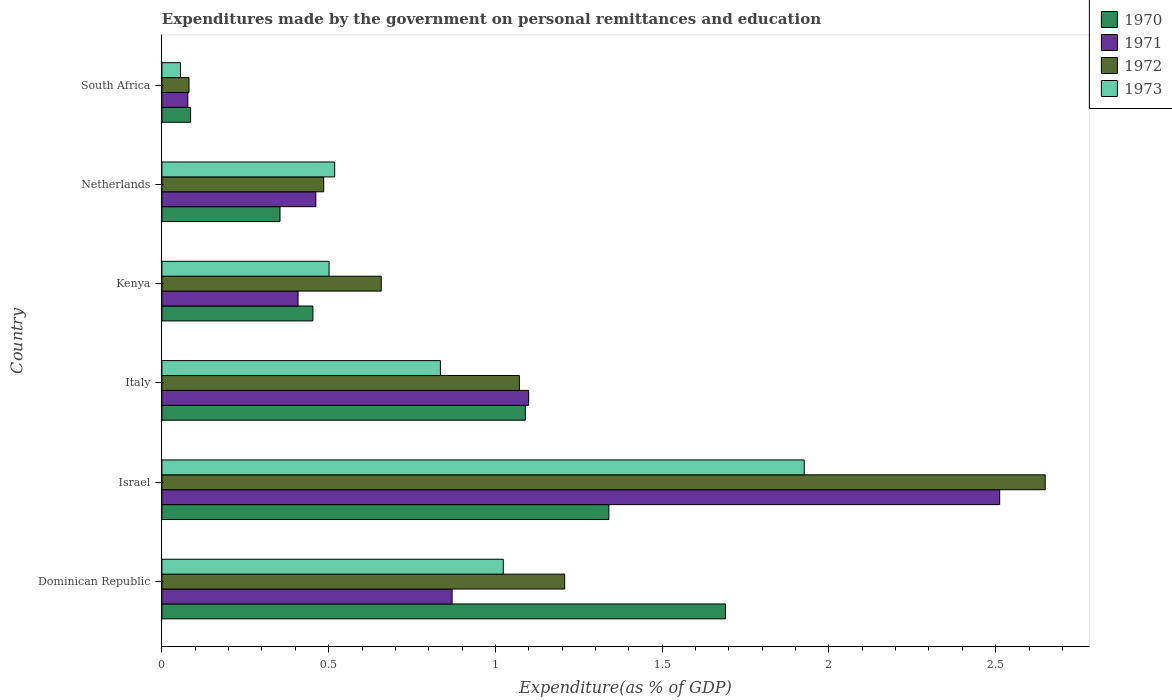How many different coloured bars are there?
Provide a succinct answer. 4. How many groups of bars are there?
Give a very brief answer. 6. How many bars are there on the 4th tick from the top?
Your answer should be very brief. 4. What is the label of the 2nd group of bars from the top?
Your answer should be very brief. Netherlands. What is the expenditures made by the government on personal remittances and education in 1971 in Kenya?
Your response must be concise. 0.41. Across all countries, what is the maximum expenditures made by the government on personal remittances and education in 1971?
Offer a terse response. 2.51. Across all countries, what is the minimum expenditures made by the government on personal remittances and education in 1971?
Your answer should be very brief. 0.08. In which country was the expenditures made by the government on personal remittances and education in 1971 minimum?
Give a very brief answer. South Africa. What is the total expenditures made by the government on personal remittances and education in 1972 in the graph?
Provide a short and direct response. 6.15. What is the difference between the expenditures made by the government on personal remittances and education in 1971 in Israel and that in Italy?
Provide a short and direct response. 1.41. What is the difference between the expenditures made by the government on personal remittances and education in 1970 in Israel and the expenditures made by the government on personal remittances and education in 1973 in South Africa?
Your answer should be very brief. 1.28. What is the average expenditures made by the government on personal remittances and education in 1970 per country?
Your response must be concise. 0.84. What is the difference between the expenditures made by the government on personal remittances and education in 1971 and expenditures made by the government on personal remittances and education in 1973 in Kenya?
Ensure brevity in your answer.  -0.09. What is the ratio of the expenditures made by the government on personal remittances and education in 1973 in Dominican Republic to that in Kenya?
Your response must be concise. 2.04. Is the expenditures made by the government on personal remittances and education in 1972 in Dominican Republic less than that in Israel?
Make the answer very short. Yes. Is the difference between the expenditures made by the government on personal remittances and education in 1971 in Israel and Netherlands greater than the difference between the expenditures made by the government on personal remittances and education in 1973 in Israel and Netherlands?
Offer a terse response. Yes. What is the difference between the highest and the second highest expenditures made by the government on personal remittances and education in 1972?
Provide a succinct answer. 1.44. What is the difference between the highest and the lowest expenditures made by the government on personal remittances and education in 1972?
Make the answer very short. 2.57. Is the sum of the expenditures made by the government on personal remittances and education in 1971 in Dominican Republic and South Africa greater than the maximum expenditures made by the government on personal remittances and education in 1970 across all countries?
Keep it short and to the point. No. Is it the case that in every country, the sum of the expenditures made by the government on personal remittances and education in 1973 and expenditures made by the government on personal remittances and education in 1972 is greater than the sum of expenditures made by the government on personal remittances and education in 1971 and expenditures made by the government on personal remittances and education in 1970?
Give a very brief answer. No. What does the 1st bar from the top in South Africa represents?
Provide a short and direct response. 1973. What does the 2nd bar from the bottom in South Africa represents?
Provide a succinct answer. 1971. How many bars are there?
Offer a terse response. 24. Are all the bars in the graph horizontal?
Offer a terse response. Yes. How many countries are there in the graph?
Your answer should be very brief. 6. Are the values on the major ticks of X-axis written in scientific E-notation?
Offer a terse response. No. Where does the legend appear in the graph?
Give a very brief answer. Top right. How many legend labels are there?
Offer a very short reply. 4. How are the legend labels stacked?
Ensure brevity in your answer.  Vertical. What is the title of the graph?
Provide a short and direct response. Expenditures made by the government on personal remittances and education. Does "1966" appear as one of the legend labels in the graph?
Offer a terse response. No. What is the label or title of the X-axis?
Offer a very short reply. Expenditure(as % of GDP). What is the Expenditure(as % of GDP) in 1970 in Dominican Republic?
Keep it short and to the point. 1.69. What is the Expenditure(as % of GDP) in 1971 in Dominican Republic?
Keep it short and to the point. 0.87. What is the Expenditure(as % of GDP) in 1972 in Dominican Republic?
Offer a terse response. 1.21. What is the Expenditure(as % of GDP) of 1973 in Dominican Republic?
Your response must be concise. 1.02. What is the Expenditure(as % of GDP) of 1970 in Israel?
Offer a very short reply. 1.34. What is the Expenditure(as % of GDP) of 1971 in Israel?
Offer a terse response. 2.51. What is the Expenditure(as % of GDP) of 1972 in Israel?
Your answer should be very brief. 2.65. What is the Expenditure(as % of GDP) of 1973 in Israel?
Provide a succinct answer. 1.93. What is the Expenditure(as % of GDP) of 1970 in Italy?
Your answer should be very brief. 1.09. What is the Expenditure(as % of GDP) of 1971 in Italy?
Provide a succinct answer. 1.1. What is the Expenditure(as % of GDP) of 1972 in Italy?
Ensure brevity in your answer.  1.07. What is the Expenditure(as % of GDP) in 1973 in Italy?
Provide a succinct answer. 0.84. What is the Expenditure(as % of GDP) in 1970 in Kenya?
Your answer should be very brief. 0.45. What is the Expenditure(as % of GDP) of 1971 in Kenya?
Provide a short and direct response. 0.41. What is the Expenditure(as % of GDP) of 1972 in Kenya?
Offer a terse response. 0.66. What is the Expenditure(as % of GDP) in 1973 in Kenya?
Make the answer very short. 0.5. What is the Expenditure(as % of GDP) in 1970 in Netherlands?
Your answer should be very brief. 0.35. What is the Expenditure(as % of GDP) in 1971 in Netherlands?
Offer a very short reply. 0.46. What is the Expenditure(as % of GDP) in 1972 in Netherlands?
Make the answer very short. 0.49. What is the Expenditure(as % of GDP) of 1973 in Netherlands?
Ensure brevity in your answer.  0.52. What is the Expenditure(as % of GDP) in 1970 in South Africa?
Your answer should be very brief. 0.09. What is the Expenditure(as % of GDP) in 1971 in South Africa?
Your answer should be compact. 0.08. What is the Expenditure(as % of GDP) in 1972 in South Africa?
Your answer should be very brief. 0.08. What is the Expenditure(as % of GDP) of 1973 in South Africa?
Give a very brief answer. 0.06. Across all countries, what is the maximum Expenditure(as % of GDP) in 1970?
Your answer should be very brief. 1.69. Across all countries, what is the maximum Expenditure(as % of GDP) of 1971?
Your answer should be very brief. 2.51. Across all countries, what is the maximum Expenditure(as % of GDP) of 1972?
Make the answer very short. 2.65. Across all countries, what is the maximum Expenditure(as % of GDP) in 1973?
Ensure brevity in your answer.  1.93. Across all countries, what is the minimum Expenditure(as % of GDP) of 1970?
Ensure brevity in your answer.  0.09. Across all countries, what is the minimum Expenditure(as % of GDP) of 1971?
Offer a very short reply. 0.08. Across all countries, what is the minimum Expenditure(as % of GDP) of 1972?
Ensure brevity in your answer.  0.08. Across all countries, what is the minimum Expenditure(as % of GDP) of 1973?
Ensure brevity in your answer.  0.06. What is the total Expenditure(as % of GDP) in 1970 in the graph?
Your response must be concise. 5.01. What is the total Expenditure(as % of GDP) in 1971 in the graph?
Offer a terse response. 5.43. What is the total Expenditure(as % of GDP) in 1972 in the graph?
Keep it short and to the point. 6.15. What is the total Expenditure(as % of GDP) of 1973 in the graph?
Ensure brevity in your answer.  4.86. What is the difference between the Expenditure(as % of GDP) of 1970 in Dominican Republic and that in Israel?
Give a very brief answer. 0.35. What is the difference between the Expenditure(as % of GDP) in 1971 in Dominican Republic and that in Israel?
Offer a very short reply. -1.64. What is the difference between the Expenditure(as % of GDP) of 1972 in Dominican Republic and that in Israel?
Provide a succinct answer. -1.44. What is the difference between the Expenditure(as % of GDP) of 1973 in Dominican Republic and that in Israel?
Provide a succinct answer. -0.9. What is the difference between the Expenditure(as % of GDP) of 1970 in Dominican Republic and that in Italy?
Provide a succinct answer. 0.6. What is the difference between the Expenditure(as % of GDP) in 1971 in Dominican Republic and that in Italy?
Provide a short and direct response. -0.23. What is the difference between the Expenditure(as % of GDP) in 1972 in Dominican Republic and that in Italy?
Provide a short and direct response. 0.14. What is the difference between the Expenditure(as % of GDP) of 1973 in Dominican Republic and that in Italy?
Make the answer very short. 0.19. What is the difference between the Expenditure(as % of GDP) of 1970 in Dominican Republic and that in Kenya?
Keep it short and to the point. 1.24. What is the difference between the Expenditure(as % of GDP) in 1971 in Dominican Republic and that in Kenya?
Your answer should be very brief. 0.46. What is the difference between the Expenditure(as % of GDP) of 1972 in Dominican Republic and that in Kenya?
Give a very brief answer. 0.55. What is the difference between the Expenditure(as % of GDP) of 1973 in Dominican Republic and that in Kenya?
Your answer should be compact. 0.52. What is the difference between the Expenditure(as % of GDP) of 1970 in Dominican Republic and that in Netherlands?
Make the answer very short. 1.34. What is the difference between the Expenditure(as % of GDP) in 1971 in Dominican Republic and that in Netherlands?
Make the answer very short. 0.41. What is the difference between the Expenditure(as % of GDP) in 1972 in Dominican Republic and that in Netherlands?
Your answer should be very brief. 0.72. What is the difference between the Expenditure(as % of GDP) of 1973 in Dominican Republic and that in Netherlands?
Your response must be concise. 0.51. What is the difference between the Expenditure(as % of GDP) in 1970 in Dominican Republic and that in South Africa?
Make the answer very short. 1.6. What is the difference between the Expenditure(as % of GDP) in 1971 in Dominican Republic and that in South Africa?
Provide a succinct answer. 0.79. What is the difference between the Expenditure(as % of GDP) in 1972 in Dominican Republic and that in South Africa?
Your response must be concise. 1.13. What is the difference between the Expenditure(as % of GDP) in 1973 in Dominican Republic and that in South Africa?
Your response must be concise. 0.97. What is the difference between the Expenditure(as % of GDP) of 1970 in Israel and that in Italy?
Your answer should be very brief. 0.25. What is the difference between the Expenditure(as % of GDP) in 1971 in Israel and that in Italy?
Your response must be concise. 1.41. What is the difference between the Expenditure(as % of GDP) of 1972 in Israel and that in Italy?
Make the answer very short. 1.58. What is the difference between the Expenditure(as % of GDP) in 1973 in Israel and that in Italy?
Keep it short and to the point. 1.09. What is the difference between the Expenditure(as % of GDP) in 1970 in Israel and that in Kenya?
Make the answer very short. 0.89. What is the difference between the Expenditure(as % of GDP) of 1971 in Israel and that in Kenya?
Provide a short and direct response. 2.1. What is the difference between the Expenditure(as % of GDP) in 1972 in Israel and that in Kenya?
Offer a very short reply. 1.99. What is the difference between the Expenditure(as % of GDP) in 1973 in Israel and that in Kenya?
Ensure brevity in your answer.  1.42. What is the difference between the Expenditure(as % of GDP) of 1970 in Israel and that in Netherlands?
Keep it short and to the point. 0.99. What is the difference between the Expenditure(as % of GDP) in 1971 in Israel and that in Netherlands?
Your answer should be very brief. 2.05. What is the difference between the Expenditure(as % of GDP) in 1972 in Israel and that in Netherlands?
Your response must be concise. 2.16. What is the difference between the Expenditure(as % of GDP) in 1973 in Israel and that in Netherlands?
Your response must be concise. 1.41. What is the difference between the Expenditure(as % of GDP) in 1970 in Israel and that in South Africa?
Your response must be concise. 1.25. What is the difference between the Expenditure(as % of GDP) in 1971 in Israel and that in South Africa?
Provide a short and direct response. 2.43. What is the difference between the Expenditure(as % of GDP) in 1972 in Israel and that in South Africa?
Offer a terse response. 2.57. What is the difference between the Expenditure(as % of GDP) of 1973 in Israel and that in South Africa?
Your answer should be very brief. 1.87. What is the difference between the Expenditure(as % of GDP) in 1970 in Italy and that in Kenya?
Your answer should be very brief. 0.64. What is the difference between the Expenditure(as % of GDP) of 1971 in Italy and that in Kenya?
Provide a short and direct response. 0.69. What is the difference between the Expenditure(as % of GDP) of 1972 in Italy and that in Kenya?
Provide a short and direct response. 0.41. What is the difference between the Expenditure(as % of GDP) in 1973 in Italy and that in Kenya?
Your answer should be very brief. 0.33. What is the difference between the Expenditure(as % of GDP) in 1970 in Italy and that in Netherlands?
Your response must be concise. 0.74. What is the difference between the Expenditure(as % of GDP) in 1971 in Italy and that in Netherlands?
Your response must be concise. 0.64. What is the difference between the Expenditure(as % of GDP) of 1972 in Italy and that in Netherlands?
Your answer should be very brief. 0.59. What is the difference between the Expenditure(as % of GDP) in 1973 in Italy and that in Netherlands?
Your answer should be very brief. 0.32. What is the difference between the Expenditure(as % of GDP) of 1970 in Italy and that in South Africa?
Keep it short and to the point. 1. What is the difference between the Expenditure(as % of GDP) in 1971 in Italy and that in South Africa?
Offer a very short reply. 1.02. What is the difference between the Expenditure(as % of GDP) of 1972 in Italy and that in South Africa?
Offer a terse response. 0.99. What is the difference between the Expenditure(as % of GDP) in 1973 in Italy and that in South Africa?
Make the answer very short. 0.78. What is the difference between the Expenditure(as % of GDP) in 1970 in Kenya and that in Netherlands?
Give a very brief answer. 0.1. What is the difference between the Expenditure(as % of GDP) of 1971 in Kenya and that in Netherlands?
Your answer should be very brief. -0.05. What is the difference between the Expenditure(as % of GDP) of 1972 in Kenya and that in Netherlands?
Give a very brief answer. 0.17. What is the difference between the Expenditure(as % of GDP) of 1973 in Kenya and that in Netherlands?
Offer a terse response. -0.02. What is the difference between the Expenditure(as % of GDP) in 1970 in Kenya and that in South Africa?
Ensure brevity in your answer.  0.37. What is the difference between the Expenditure(as % of GDP) in 1971 in Kenya and that in South Africa?
Your response must be concise. 0.33. What is the difference between the Expenditure(as % of GDP) of 1972 in Kenya and that in South Africa?
Offer a very short reply. 0.58. What is the difference between the Expenditure(as % of GDP) of 1973 in Kenya and that in South Africa?
Give a very brief answer. 0.45. What is the difference between the Expenditure(as % of GDP) of 1970 in Netherlands and that in South Africa?
Offer a very short reply. 0.27. What is the difference between the Expenditure(as % of GDP) in 1971 in Netherlands and that in South Africa?
Provide a succinct answer. 0.38. What is the difference between the Expenditure(as % of GDP) in 1972 in Netherlands and that in South Africa?
Provide a succinct answer. 0.4. What is the difference between the Expenditure(as % of GDP) in 1973 in Netherlands and that in South Africa?
Ensure brevity in your answer.  0.46. What is the difference between the Expenditure(as % of GDP) in 1970 in Dominican Republic and the Expenditure(as % of GDP) in 1971 in Israel?
Your response must be concise. -0.82. What is the difference between the Expenditure(as % of GDP) of 1970 in Dominican Republic and the Expenditure(as % of GDP) of 1972 in Israel?
Give a very brief answer. -0.96. What is the difference between the Expenditure(as % of GDP) of 1970 in Dominican Republic and the Expenditure(as % of GDP) of 1973 in Israel?
Provide a short and direct response. -0.24. What is the difference between the Expenditure(as % of GDP) in 1971 in Dominican Republic and the Expenditure(as % of GDP) in 1972 in Israel?
Provide a short and direct response. -1.78. What is the difference between the Expenditure(as % of GDP) of 1971 in Dominican Republic and the Expenditure(as % of GDP) of 1973 in Israel?
Offer a terse response. -1.06. What is the difference between the Expenditure(as % of GDP) in 1972 in Dominican Republic and the Expenditure(as % of GDP) in 1973 in Israel?
Give a very brief answer. -0.72. What is the difference between the Expenditure(as % of GDP) of 1970 in Dominican Republic and the Expenditure(as % of GDP) of 1971 in Italy?
Your answer should be very brief. 0.59. What is the difference between the Expenditure(as % of GDP) in 1970 in Dominican Republic and the Expenditure(as % of GDP) in 1972 in Italy?
Ensure brevity in your answer.  0.62. What is the difference between the Expenditure(as % of GDP) in 1970 in Dominican Republic and the Expenditure(as % of GDP) in 1973 in Italy?
Provide a succinct answer. 0.85. What is the difference between the Expenditure(as % of GDP) of 1971 in Dominican Republic and the Expenditure(as % of GDP) of 1972 in Italy?
Give a very brief answer. -0.2. What is the difference between the Expenditure(as % of GDP) of 1971 in Dominican Republic and the Expenditure(as % of GDP) of 1973 in Italy?
Your answer should be compact. 0.04. What is the difference between the Expenditure(as % of GDP) of 1972 in Dominican Republic and the Expenditure(as % of GDP) of 1973 in Italy?
Provide a short and direct response. 0.37. What is the difference between the Expenditure(as % of GDP) of 1970 in Dominican Republic and the Expenditure(as % of GDP) of 1971 in Kenya?
Give a very brief answer. 1.28. What is the difference between the Expenditure(as % of GDP) in 1970 in Dominican Republic and the Expenditure(as % of GDP) in 1972 in Kenya?
Your response must be concise. 1.03. What is the difference between the Expenditure(as % of GDP) in 1970 in Dominican Republic and the Expenditure(as % of GDP) in 1973 in Kenya?
Your response must be concise. 1.19. What is the difference between the Expenditure(as % of GDP) in 1971 in Dominican Republic and the Expenditure(as % of GDP) in 1972 in Kenya?
Ensure brevity in your answer.  0.21. What is the difference between the Expenditure(as % of GDP) of 1971 in Dominican Republic and the Expenditure(as % of GDP) of 1973 in Kenya?
Make the answer very short. 0.37. What is the difference between the Expenditure(as % of GDP) in 1972 in Dominican Republic and the Expenditure(as % of GDP) in 1973 in Kenya?
Offer a terse response. 0.71. What is the difference between the Expenditure(as % of GDP) of 1970 in Dominican Republic and the Expenditure(as % of GDP) of 1971 in Netherlands?
Provide a short and direct response. 1.23. What is the difference between the Expenditure(as % of GDP) of 1970 in Dominican Republic and the Expenditure(as % of GDP) of 1972 in Netherlands?
Your response must be concise. 1.2. What is the difference between the Expenditure(as % of GDP) in 1970 in Dominican Republic and the Expenditure(as % of GDP) in 1973 in Netherlands?
Keep it short and to the point. 1.17. What is the difference between the Expenditure(as % of GDP) in 1971 in Dominican Republic and the Expenditure(as % of GDP) in 1972 in Netherlands?
Your response must be concise. 0.39. What is the difference between the Expenditure(as % of GDP) of 1971 in Dominican Republic and the Expenditure(as % of GDP) of 1973 in Netherlands?
Your response must be concise. 0.35. What is the difference between the Expenditure(as % of GDP) in 1972 in Dominican Republic and the Expenditure(as % of GDP) in 1973 in Netherlands?
Offer a terse response. 0.69. What is the difference between the Expenditure(as % of GDP) in 1970 in Dominican Republic and the Expenditure(as % of GDP) in 1971 in South Africa?
Provide a short and direct response. 1.61. What is the difference between the Expenditure(as % of GDP) of 1970 in Dominican Republic and the Expenditure(as % of GDP) of 1972 in South Africa?
Make the answer very short. 1.61. What is the difference between the Expenditure(as % of GDP) in 1970 in Dominican Republic and the Expenditure(as % of GDP) in 1973 in South Africa?
Your answer should be compact. 1.63. What is the difference between the Expenditure(as % of GDP) in 1971 in Dominican Republic and the Expenditure(as % of GDP) in 1972 in South Africa?
Your answer should be very brief. 0.79. What is the difference between the Expenditure(as % of GDP) in 1971 in Dominican Republic and the Expenditure(as % of GDP) in 1973 in South Africa?
Provide a succinct answer. 0.81. What is the difference between the Expenditure(as % of GDP) in 1972 in Dominican Republic and the Expenditure(as % of GDP) in 1973 in South Africa?
Provide a succinct answer. 1.15. What is the difference between the Expenditure(as % of GDP) in 1970 in Israel and the Expenditure(as % of GDP) in 1971 in Italy?
Give a very brief answer. 0.24. What is the difference between the Expenditure(as % of GDP) of 1970 in Israel and the Expenditure(as % of GDP) of 1972 in Italy?
Your answer should be compact. 0.27. What is the difference between the Expenditure(as % of GDP) of 1970 in Israel and the Expenditure(as % of GDP) of 1973 in Italy?
Your answer should be very brief. 0.51. What is the difference between the Expenditure(as % of GDP) of 1971 in Israel and the Expenditure(as % of GDP) of 1972 in Italy?
Your answer should be compact. 1.44. What is the difference between the Expenditure(as % of GDP) of 1971 in Israel and the Expenditure(as % of GDP) of 1973 in Italy?
Ensure brevity in your answer.  1.68. What is the difference between the Expenditure(as % of GDP) in 1972 in Israel and the Expenditure(as % of GDP) in 1973 in Italy?
Keep it short and to the point. 1.81. What is the difference between the Expenditure(as % of GDP) of 1970 in Israel and the Expenditure(as % of GDP) of 1971 in Kenya?
Your answer should be very brief. 0.93. What is the difference between the Expenditure(as % of GDP) of 1970 in Israel and the Expenditure(as % of GDP) of 1972 in Kenya?
Your answer should be compact. 0.68. What is the difference between the Expenditure(as % of GDP) of 1970 in Israel and the Expenditure(as % of GDP) of 1973 in Kenya?
Offer a very short reply. 0.84. What is the difference between the Expenditure(as % of GDP) in 1971 in Israel and the Expenditure(as % of GDP) in 1972 in Kenya?
Your answer should be compact. 1.85. What is the difference between the Expenditure(as % of GDP) in 1971 in Israel and the Expenditure(as % of GDP) in 1973 in Kenya?
Keep it short and to the point. 2.01. What is the difference between the Expenditure(as % of GDP) in 1972 in Israel and the Expenditure(as % of GDP) in 1973 in Kenya?
Your answer should be compact. 2.15. What is the difference between the Expenditure(as % of GDP) of 1970 in Israel and the Expenditure(as % of GDP) of 1971 in Netherlands?
Make the answer very short. 0.88. What is the difference between the Expenditure(as % of GDP) in 1970 in Israel and the Expenditure(as % of GDP) in 1972 in Netherlands?
Make the answer very short. 0.85. What is the difference between the Expenditure(as % of GDP) in 1970 in Israel and the Expenditure(as % of GDP) in 1973 in Netherlands?
Keep it short and to the point. 0.82. What is the difference between the Expenditure(as % of GDP) of 1971 in Israel and the Expenditure(as % of GDP) of 1972 in Netherlands?
Ensure brevity in your answer.  2.03. What is the difference between the Expenditure(as % of GDP) of 1971 in Israel and the Expenditure(as % of GDP) of 1973 in Netherlands?
Provide a short and direct response. 1.99. What is the difference between the Expenditure(as % of GDP) in 1972 in Israel and the Expenditure(as % of GDP) in 1973 in Netherlands?
Your response must be concise. 2.13. What is the difference between the Expenditure(as % of GDP) in 1970 in Israel and the Expenditure(as % of GDP) in 1971 in South Africa?
Make the answer very short. 1.26. What is the difference between the Expenditure(as % of GDP) in 1970 in Israel and the Expenditure(as % of GDP) in 1972 in South Africa?
Offer a very short reply. 1.26. What is the difference between the Expenditure(as % of GDP) of 1970 in Israel and the Expenditure(as % of GDP) of 1973 in South Africa?
Provide a succinct answer. 1.28. What is the difference between the Expenditure(as % of GDP) of 1971 in Israel and the Expenditure(as % of GDP) of 1972 in South Africa?
Your answer should be very brief. 2.43. What is the difference between the Expenditure(as % of GDP) in 1971 in Israel and the Expenditure(as % of GDP) in 1973 in South Africa?
Your response must be concise. 2.46. What is the difference between the Expenditure(as % of GDP) of 1972 in Israel and the Expenditure(as % of GDP) of 1973 in South Africa?
Provide a short and direct response. 2.59. What is the difference between the Expenditure(as % of GDP) in 1970 in Italy and the Expenditure(as % of GDP) in 1971 in Kenya?
Offer a terse response. 0.68. What is the difference between the Expenditure(as % of GDP) in 1970 in Italy and the Expenditure(as % of GDP) in 1972 in Kenya?
Your answer should be very brief. 0.43. What is the difference between the Expenditure(as % of GDP) in 1970 in Italy and the Expenditure(as % of GDP) in 1973 in Kenya?
Offer a terse response. 0.59. What is the difference between the Expenditure(as % of GDP) in 1971 in Italy and the Expenditure(as % of GDP) in 1972 in Kenya?
Your response must be concise. 0.44. What is the difference between the Expenditure(as % of GDP) of 1971 in Italy and the Expenditure(as % of GDP) of 1973 in Kenya?
Your answer should be compact. 0.6. What is the difference between the Expenditure(as % of GDP) in 1972 in Italy and the Expenditure(as % of GDP) in 1973 in Kenya?
Ensure brevity in your answer.  0.57. What is the difference between the Expenditure(as % of GDP) of 1970 in Italy and the Expenditure(as % of GDP) of 1971 in Netherlands?
Your answer should be compact. 0.63. What is the difference between the Expenditure(as % of GDP) in 1970 in Italy and the Expenditure(as % of GDP) in 1972 in Netherlands?
Give a very brief answer. 0.6. What is the difference between the Expenditure(as % of GDP) in 1970 in Italy and the Expenditure(as % of GDP) in 1973 in Netherlands?
Ensure brevity in your answer.  0.57. What is the difference between the Expenditure(as % of GDP) of 1971 in Italy and the Expenditure(as % of GDP) of 1972 in Netherlands?
Your answer should be very brief. 0.61. What is the difference between the Expenditure(as % of GDP) in 1971 in Italy and the Expenditure(as % of GDP) in 1973 in Netherlands?
Your response must be concise. 0.58. What is the difference between the Expenditure(as % of GDP) of 1972 in Italy and the Expenditure(as % of GDP) of 1973 in Netherlands?
Your answer should be compact. 0.55. What is the difference between the Expenditure(as % of GDP) in 1970 in Italy and the Expenditure(as % of GDP) in 1971 in South Africa?
Make the answer very short. 1.01. What is the difference between the Expenditure(as % of GDP) in 1970 in Italy and the Expenditure(as % of GDP) in 1972 in South Africa?
Offer a terse response. 1.01. What is the difference between the Expenditure(as % of GDP) of 1970 in Italy and the Expenditure(as % of GDP) of 1973 in South Africa?
Give a very brief answer. 1.03. What is the difference between the Expenditure(as % of GDP) of 1971 in Italy and the Expenditure(as % of GDP) of 1972 in South Africa?
Your answer should be very brief. 1.02. What is the difference between the Expenditure(as % of GDP) of 1971 in Italy and the Expenditure(as % of GDP) of 1973 in South Africa?
Your response must be concise. 1.04. What is the difference between the Expenditure(as % of GDP) in 1970 in Kenya and the Expenditure(as % of GDP) in 1971 in Netherlands?
Make the answer very short. -0.01. What is the difference between the Expenditure(as % of GDP) of 1970 in Kenya and the Expenditure(as % of GDP) of 1972 in Netherlands?
Make the answer very short. -0.03. What is the difference between the Expenditure(as % of GDP) in 1970 in Kenya and the Expenditure(as % of GDP) in 1973 in Netherlands?
Your answer should be very brief. -0.07. What is the difference between the Expenditure(as % of GDP) in 1971 in Kenya and the Expenditure(as % of GDP) in 1972 in Netherlands?
Ensure brevity in your answer.  -0.08. What is the difference between the Expenditure(as % of GDP) of 1971 in Kenya and the Expenditure(as % of GDP) of 1973 in Netherlands?
Your response must be concise. -0.11. What is the difference between the Expenditure(as % of GDP) in 1972 in Kenya and the Expenditure(as % of GDP) in 1973 in Netherlands?
Offer a very short reply. 0.14. What is the difference between the Expenditure(as % of GDP) of 1970 in Kenya and the Expenditure(as % of GDP) of 1972 in South Africa?
Provide a short and direct response. 0.37. What is the difference between the Expenditure(as % of GDP) of 1970 in Kenya and the Expenditure(as % of GDP) of 1973 in South Africa?
Make the answer very short. 0.4. What is the difference between the Expenditure(as % of GDP) of 1971 in Kenya and the Expenditure(as % of GDP) of 1972 in South Africa?
Your response must be concise. 0.33. What is the difference between the Expenditure(as % of GDP) in 1971 in Kenya and the Expenditure(as % of GDP) in 1973 in South Africa?
Your response must be concise. 0.35. What is the difference between the Expenditure(as % of GDP) in 1972 in Kenya and the Expenditure(as % of GDP) in 1973 in South Africa?
Provide a succinct answer. 0.6. What is the difference between the Expenditure(as % of GDP) in 1970 in Netherlands and the Expenditure(as % of GDP) in 1971 in South Africa?
Provide a succinct answer. 0.28. What is the difference between the Expenditure(as % of GDP) of 1970 in Netherlands and the Expenditure(as % of GDP) of 1972 in South Africa?
Ensure brevity in your answer.  0.27. What is the difference between the Expenditure(as % of GDP) in 1970 in Netherlands and the Expenditure(as % of GDP) in 1973 in South Africa?
Provide a short and direct response. 0.3. What is the difference between the Expenditure(as % of GDP) in 1971 in Netherlands and the Expenditure(as % of GDP) in 1972 in South Africa?
Provide a short and direct response. 0.38. What is the difference between the Expenditure(as % of GDP) in 1971 in Netherlands and the Expenditure(as % of GDP) in 1973 in South Africa?
Offer a terse response. 0.41. What is the difference between the Expenditure(as % of GDP) of 1972 in Netherlands and the Expenditure(as % of GDP) of 1973 in South Africa?
Make the answer very short. 0.43. What is the average Expenditure(as % of GDP) of 1970 per country?
Your answer should be very brief. 0.84. What is the average Expenditure(as % of GDP) of 1971 per country?
Offer a terse response. 0.9. What is the average Expenditure(as % of GDP) of 1972 per country?
Provide a succinct answer. 1.03. What is the average Expenditure(as % of GDP) in 1973 per country?
Your answer should be compact. 0.81. What is the difference between the Expenditure(as % of GDP) in 1970 and Expenditure(as % of GDP) in 1971 in Dominican Republic?
Give a very brief answer. 0.82. What is the difference between the Expenditure(as % of GDP) in 1970 and Expenditure(as % of GDP) in 1972 in Dominican Republic?
Your answer should be compact. 0.48. What is the difference between the Expenditure(as % of GDP) in 1970 and Expenditure(as % of GDP) in 1973 in Dominican Republic?
Your answer should be compact. 0.67. What is the difference between the Expenditure(as % of GDP) in 1971 and Expenditure(as % of GDP) in 1972 in Dominican Republic?
Provide a succinct answer. -0.34. What is the difference between the Expenditure(as % of GDP) of 1971 and Expenditure(as % of GDP) of 1973 in Dominican Republic?
Ensure brevity in your answer.  -0.15. What is the difference between the Expenditure(as % of GDP) of 1972 and Expenditure(as % of GDP) of 1973 in Dominican Republic?
Give a very brief answer. 0.18. What is the difference between the Expenditure(as % of GDP) of 1970 and Expenditure(as % of GDP) of 1971 in Israel?
Provide a short and direct response. -1.17. What is the difference between the Expenditure(as % of GDP) in 1970 and Expenditure(as % of GDP) in 1972 in Israel?
Your answer should be compact. -1.31. What is the difference between the Expenditure(as % of GDP) in 1970 and Expenditure(as % of GDP) in 1973 in Israel?
Offer a terse response. -0.59. What is the difference between the Expenditure(as % of GDP) of 1971 and Expenditure(as % of GDP) of 1972 in Israel?
Provide a succinct answer. -0.14. What is the difference between the Expenditure(as % of GDP) in 1971 and Expenditure(as % of GDP) in 1973 in Israel?
Ensure brevity in your answer.  0.59. What is the difference between the Expenditure(as % of GDP) in 1972 and Expenditure(as % of GDP) in 1973 in Israel?
Offer a very short reply. 0.72. What is the difference between the Expenditure(as % of GDP) in 1970 and Expenditure(as % of GDP) in 1971 in Italy?
Offer a very short reply. -0.01. What is the difference between the Expenditure(as % of GDP) in 1970 and Expenditure(as % of GDP) in 1972 in Italy?
Your answer should be compact. 0.02. What is the difference between the Expenditure(as % of GDP) in 1970 and Expenditure(as % of GDP) in 1973 in Italy?
Ensure brevity in your answer.  0.25. What is the difference between the Expenditure(as % of GDP) of 1971 and Expenditure(as % of GDP) of 1972 in Italy?
Give a very brief answer. 0.03. What is the difference between the Expenditure(as % of GDP) of 1971 and Expenditure(as % of GDP) of 1973 in Italy?
Make the answer very short. 0.26. What is the difference between the Expenditure(as % of GDP) of 1972 and Expenditure(as % of GDP) of 1973 in Italy?
Your answer should be compact. 0.24. What is the difference between the Expenditure(as % of GDP) of 1970 and Expenditure(as % of GDP) of 1971 in Kenya?
Ensure brevity in your answer.  0.04. What is the difference between the Expenditure(as % of GDP) of 1970 and Expenditure(as % of GDP) of 1972 in Kenya?
Your answer should be compact. -0.2. What is the difference between the Expenditure(as % of GDP) in 1970 and Expenditure(as % of GDP) in 1973 in Kenya?
Your answer should be compact. -0.05. What is the difference between the Expenditure(as % of GDP) in 1971 and Expenditure(as % of GDP) in 1972 in Kenya?
Give a very brief answer. -0.25. What is the difference between the Expenditure(as % of GDP) of 1971 and Expenditure(as % of GDP) of 1973 in Kenya?
Offer a very short reply. -0.09. What is the difference between the Expenditure(as % of GDP) of 1972 and Expenditure(as % of GDP) of 1973 in Kenya?
Provide a short and direct response. 0.16. What is the difference between the Expenditure(as % of GDP) in 1970 and Expenditure(as % of GDP) in 1971 in Netherlands?
Make the answer very short. -0.11. What is the difference between the Expenditure(as % of GDP) of 1970 and Expenditure(as % of GDP) of 1972 in Netherlands?
Make the answer very short. -0.13. What is the difference between the Expenditure(as % of GDP) in 1970 and Expenditure(as % of GDP) in 1973 in Netherlands?
Ensure brevity in your answer.  -0.16. What is the difference between the Expenditure(as % of GDP) of 1971 and Expenditure(as % of GDP) of 1972 in Netherlands?
Keep it short and to the point. -0.02. What is the difference between the Expenditure(as % of GDP) of 1971 and Expenditure(as % of GDP) of 1973 in Netherlands?
Provide a short and direct response. -0.06. What is the difference between the Expenditure(as % of GDP) of 1972 and Expenditure(as % of GDP) of 1973 in Netherlands?
Your answer should be compact. -0.03. What is the difference between the Expenditure(as % of GDP) of 1970 and Expenditure(as % of GDP) of 1971 in South Africa?
Your response must be concise. 0.01. What is the difference between the Expenditure(as % of GDP) in 1970 and Expenditure(as % of GDP) in 1972 in South Africa?
Your response must be concise. 0. What is the difference between the Expenditure(as % of GDP) in 1970 and Expenditure(as % of GDP) in 1973 in South Africa?
Keep it short and to the point. 0.03. What is the difference between the Expenditure(as % of GDP) in 1971 and Expenditure(as % of GDP) in 1972 in South Africa?
Your answer should be very brief. -0. What is the difference between the Expenditure(as % of GDP) of 1971 and Expenditure(as % of GDP) of 1973 in South Africa?
Keep it short and to the point. 0.02. What is the difference between the Expenditure(as % of GDP) of 1972 and Expenditure(as % of GDP) of 1973 in South Africa?
Ensure brevity in your answer.  0.03. What is the ratio of the Expenditure(as % of GDP) in 1970 in Dominican Republic to that in Israel?
Your answer should be very brief. 1.26. What is the ratio of the Expenditure(as % of GDP) in 1971 in Dominican Republic to that in Israel?
Ensure brevity in your answer.  0.35. What is the ratio of the Expenditure(as % of GDP) of 1972 in Dominican Republic to that in Israel?
Ensure brevity in your answer.  0.46. What is the ratio of the Expenditure(as % of GDP) in 1973 in Dominican Republic to that in Israel?
Make the answer very short. 0.53. What is the ratio of the Expenditure(as % of GDP) in 1970 in Dominican Republic to that in Italy?
Provide a short and direct response. 1.55. What is the ratio of the Expenditure(as % of GDP) in 1971 in Dominican Republic to that in Italy?
Make the answer very short. 0.79. What is the ratio of the Expenditure(as % of GDP) in 1972 in Dominican Republic to that in Italy?
Keep it short and to the point. 1.13. What is the ratio of the Expenditure(as % of GDP) of 1973 in Dominican Republic to that in Italy?
Keep it short and to the point. 1.23. What is the ratio of the Expenditure(as % of GDP) in 1970 in Dominican Republic to that in Kenya?
Your answer should be very brief. 3.73. What is the ratio of the Expenditure(as % of GDP) in 1971 in Dominican Republic to that in Kenya?
Your response must be concise. 2.13. What is the ratio of the Expenditure(as % of GDP) of 1972 in Dominican Republic to that in Kenya?
Your answer should be very brief. 1.84. What is the ratio of the Expenditure(as % of GDP) of 1973 in Dominican Republic to that in Kenya?
Your response must be concise. 2.04. What is the ratio of the Expenditure(as % of GDP) in 1970 in Dominican Republic to that in Netherlands?
Your response must be concise. 4.77. What is the ratio of the Expenditure(as % of GDP) in 1971 in Dominican Republic to that in Netherlands?
Offer a terse response. 1.89. What is the ratio of the Expenditure(as % of GDP) in 1972 in Dominican Republic to that in Netherlands?
Provide a succinct answer. 2.49. What is the ratio of the Expenditure(as % of GDP) in 1973 in Dominican Republic to that in Netherlands?
Your answer should be very brief. 1.98. What is the ratio of the Expenditure(as % of GDP) of 1970 in Dominican Republic to that in South Africa?
Your response must be concise. 19.65. What is the ratio of the Expenditure(as % of GDP) of 1971 in Dominican Republic to that in South Africa?
Your answer should be very brief. 11.18. What is the ratio of the Expenditure(as % of GDP) of 1972 in Dominican Republic to that in South Africa?
Your answer should be compact. 14.85. What is the ratio of the Expenditure(as % of GDP) in 1973 in Dominican Republic to that in South Africa?
Your response must be concise. 18.34. What is the ratio of the Expenditure(as % of GDP) of 1970 in Israel to that in Italy?
Offer a terse response. 1.23. What is the ratio of the Expenditure(as % of GDP) of 1971 in Israel to that in Italy?
Give a very brief answer. 2.28. What is the ratio of the Expenditure(as % of GDP) of 1972 in Israel to that in Italy?
Your response must be concise. 2.47. What is the ratio of the Expenditure(as % of GDP) in 1973 in Israel to that in Italy?
Offer a terse response. 2.31. What is the ratio of the Expenditure(as % of GDP) in 1970 in Israel to that in Kenya?
Provide a short and direct response. 2.96. What is the ratio of the Expenditure(as % of GDP) of 1971 in Israel to that in Kenya?
Your answer should be very brief. 6.15. What is the ratio of the Expenditure(as % of GDP) in 1972 in Israel to that in Kenya?
Ensure brevity in your answer.  4.03. What is the ratio of the Expenditure(as % of GDP) of 1973 in Israel to that in Kenya?
Provide a succinct answer. 3.84. What is the ratio of the Expenditure(as % of GDP) in 1970 in Israel to that in Netherlands?
Offer a terse response. 3.78. What is the ratio of the Expenditure(as % of GDP) of 1971 in Israel to that in Netherlands?
Your response must be concise. 5.44. What is the ratio of the Expenditure(as % of GDP) of 1972 in Israel to that in Netherlands?
Your answer should be very brief. 5.46. What is the ratio of the Expenditure(as % of GDP) in 1973 in Israel to that in Netherlands?
Provide a short and direct response. 3.72. What is the ratio of the Expenditure(as % of GDP) of 1970 in Israel to that in South Africa?
Your answer should be very brief. 15.58. What is the ratio of the Expenditure(as % of GDP) in 1971 in Israel to that in South Africa?
Your answer should be very brief. 32.29. What is the ratio of the Expenditure(as % of GDP) in 1972 in Israel to that in South Africa?
Offer a very short reply. 32.58. What is the ratio of the Expenditure(as % of GDP) in 1973 in Israel to that in South Africa?
Provide a succinct answer. 34.5. What is the ratio of the Expenditure(as % of GDP) in 1970 in Italy to that in Kenya?
Ensure brevity in your answer.  2.41. What is the ratio of the Expenditure(as % of GDP) in 1971 in Italy to that in Kenya?
Provide a short and direct response. 2.69. What is the ratio of the Expenditure(as % of GDP) of 1972 in Italy to that in Kenya?
Provide a short and direct response. 1.63. What is the ratio of the Expenditure(as % of GDP) in 1973 in Italy to that in Kenya?
Your answer should be very brief. 1.67. What is the ratio of the Expenditure(as % of GDP) in 1970 in Italy to that in Netherlands?
Offer a very short reply. 3.08. What is the ratio of the Expenditure(as % of GDP) of 1971 in Italy to that in Netherlands?
Provide a succinct answer. 2.38. What is the ratio of the Expenditure(as % of GDP) in 1972 in Italy to that in Netherlands?
Provide a short and direct response. 2.21. What is the ratio of the Expenditure(as % of GDP) in 1973 in Italy to that in Netherlands?
Make the answer very short. 1.61. What is the ratio of the Expenditure(as % of GDP) in 1970 in Italy to that in South Africa?
Your answer should be compact. 12.67. What is the ratio of the Expenditure(as % of GDP) in 1971 in Italy to that in South Africa?
Provide a short and direct response. 14.13. What is the ratio of the Expenditure(as % of GDP) of 1972 in Italy to that in South Africa?
Provide a short and direct response. 13.18. What is the ratio of the Expenditure(as % of GDP) of 1973 in Italy to that in South Africa?
Your answer should be very brief. 14.96. What is the ratio of the Expenditure(as % of GDP) in 1970 in Kenya to that in Netherlands?
Offer a very short reply. 1.28. What is the ratio of the Expenditure(as % of GDP) in 1971 in Kenya to that in Netherlands?
Keep it short and to the point. 0.88. What is the ratio of the Expenditure(as % of GDP) of 1972 in Kenya to that in Netherlands?
Your response must be concise. 1.36. What is the ratio of the Expenditure(as % of GDP) in 1973 in Kenya to that in Netherlands?
Provide a succinct answer. 0.97. What is the ratio of the Expenditure(as % of GDP) in 1970 in Kenya to that in South Africa?
Your answer should be very brief. 5.26. What is the ratio of the Expenditure(as % of GDP) in 1971 in Kenya to that in South Africa?
Provide a succinct answer. 5.25. What is the ratio of the Expenditure(as % of GDP) of 1972 in Kenya to that in South Africa?
Provide a succinct answer. 8.09. What is the ratio of the Expenditure(as % of GDP) of 1973 in Kenya to that in South Africa?
Your response must be concise. 8.98. What is the ratio of the Expenditure(as % of GDP) in 1970 in Netherlands to that in South Africa?
Keep it short and to the point. 4.12. What is the ratio of the Expenditure(as % of GDP) of 1971 in Netherlands to that in South Africa?
Offer a terse response. 5.93. What is the ratio of the Expenditure(as % of GDP) in 1972 in Netherlands to that in South Africa?
Your response must be concise. 5.97. What is the ratio of the Expenditure(as % of GDP) in 1973 in Netherlands to that in South Africa?
Your answer should be compact. 9.28. What is the difference between the highest and the second highest Expenditure(as % of GDP) in 1970?
Provide a succinct answer. 0.35. What is the difference between the highest and the second highest Expenditure(as % of GDP) in 1971?
Give a very brief answer. 1.41. What is the difference between the highest and the second highest Expenditure(as % of GDP) of 1972?
Provide a short and direct response. 1.44. What is the difference between the highest and the second highest Expenditure(as % of GDP) in 1973?
Offer a terse response. 0.9. What is the difference between the highest and the lowest Expenditure(as % of GDP) of 1970?
Make the answer very short. 1.6. What is the difference between the highest and the lowest Expenditure(as % of GDP) of 1971?
Make the answer very short. 2.43. What is the difference between the highest and the lowest Expenditure(as % of GDP) in 1972?
Offer a terse response. 2.57. What is the difference between the highest and the lowest Expenditure(as % of GDP) in 1973?
Ensure brevity in your answer.  1.87. 